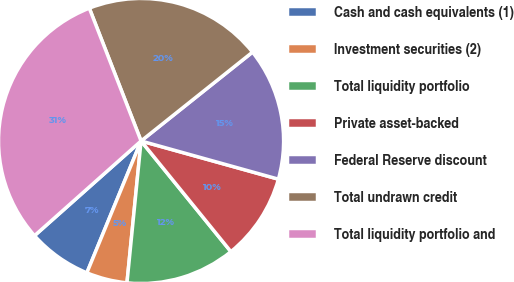Convert chart. <chart><loc_0><loc_0><loc_500><loc_500><pie_chart><fcel>Cash and cash equivalents (1)<fcel>Investment securities (2)<fcel>Total liquidity portfolio<fcel>Private asset-backed<fcel>Federal Reserve discount<fcel>Total undrawn credit<fcel>Total liquidity portfolio and<nl><fcel>7.23%<fcel>4.63%<fcel>12.43%<fcel>9.83%<fcel>15.03%<fcel>20.2%<fcel>30.65%<nl></chart> 